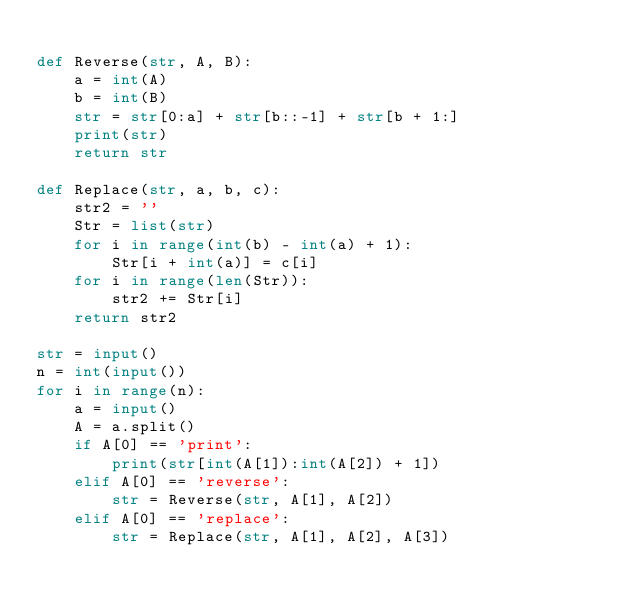Convert code to text. <code><loc_0><loc_0><loc_500><loc_500><_Python_>  
def Reverse(str, A, B):
    a = int(A)
    b = int(B)
    str = str[0:a] + str[b::-1] + str[b + 1:]
    print(str)
    return str

def Replace(str, a, b, c):
    str2 = ''
    Str = list(str)
    for i in range(int(b) - int(a) + 1):
        Str[i + int(a)] = c[i]
    for i in range(len(Str)):
        str2 += Str[i]
    return str2

str = input()
n = int(input())
for i in range(n):
    a = input()
    A = a.split()
    if A[0] == 'print':
        print(str[int(A[1]):int(A[2]) + 1])
    elif A[0] == 'reverse':
        str = Reverse(str, A[1], A[2])
    elif A[0] == 'replace':
        str = Replace(str, A[1], A[2], A[3])
</code> 